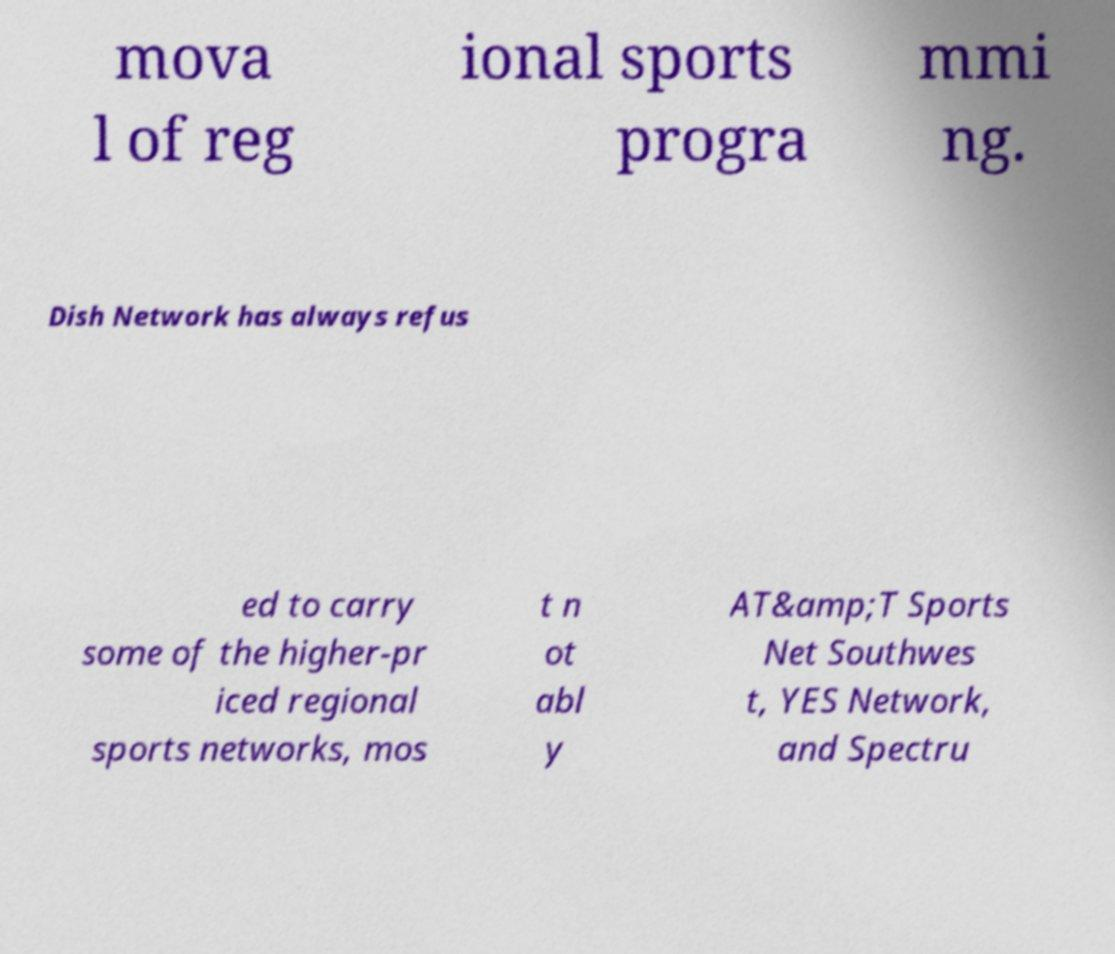Please identify and transcribe the text found in this image. mova l of reg ional sports progra mmi ng. Dish Network has always refus ed to carry some of the higher-pr iced regional sports networks, mos t n ot abl y AT&amp;T Sports Net Southwes t, YES Network, and Spectru 